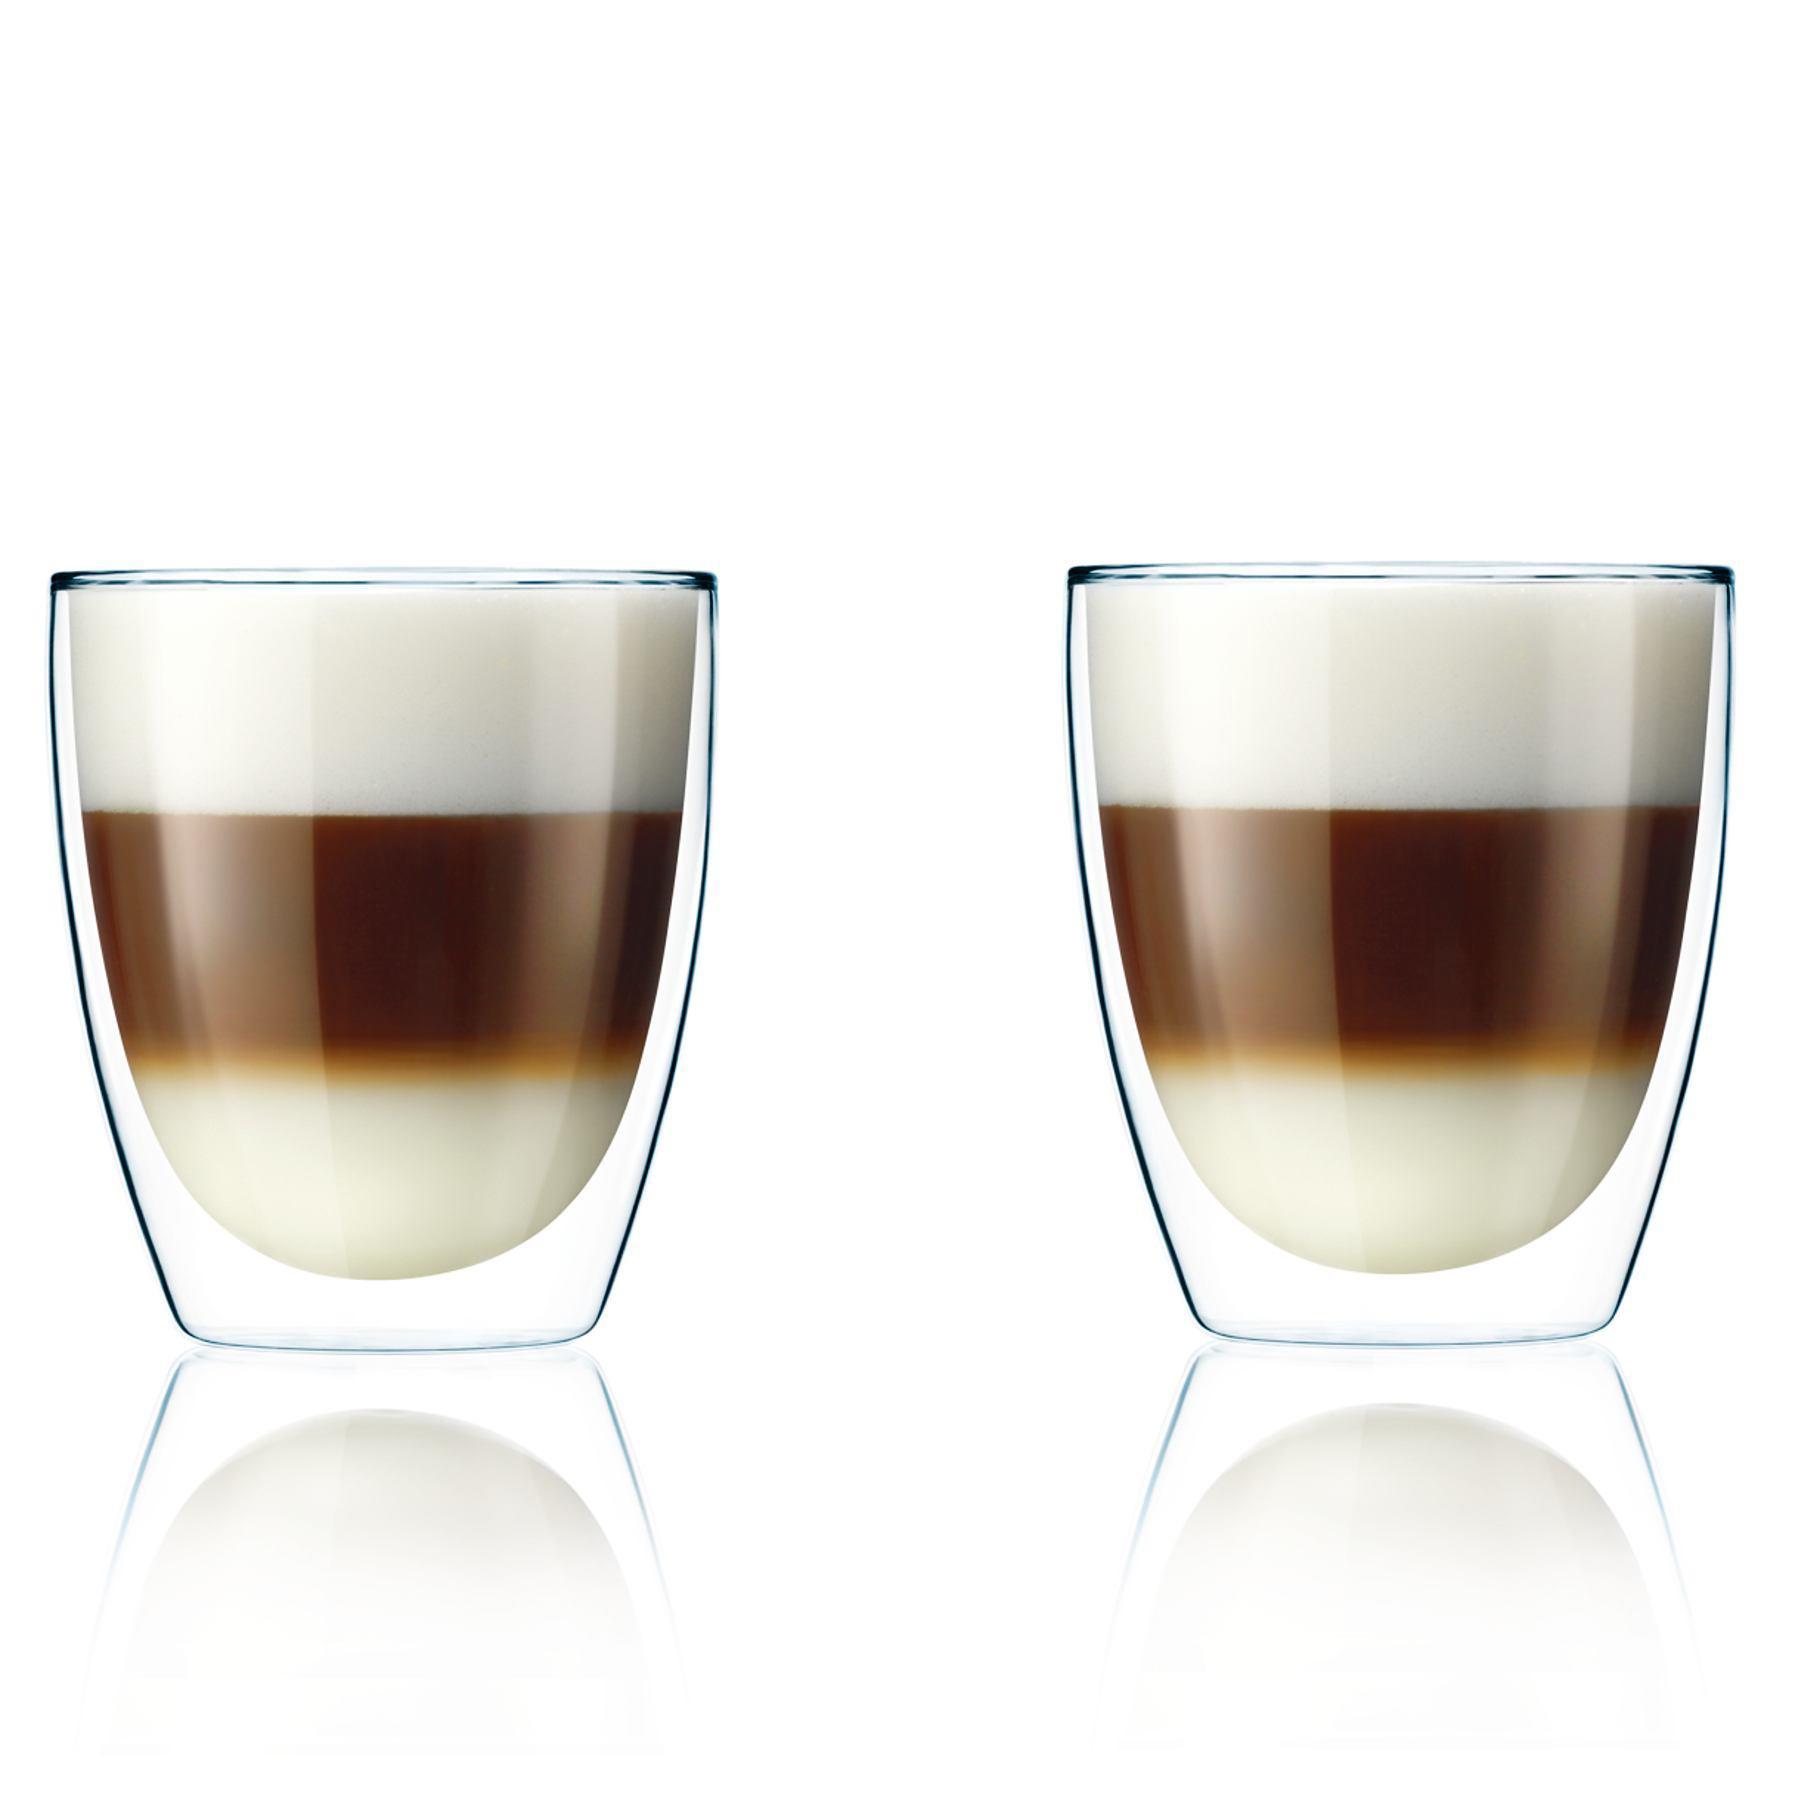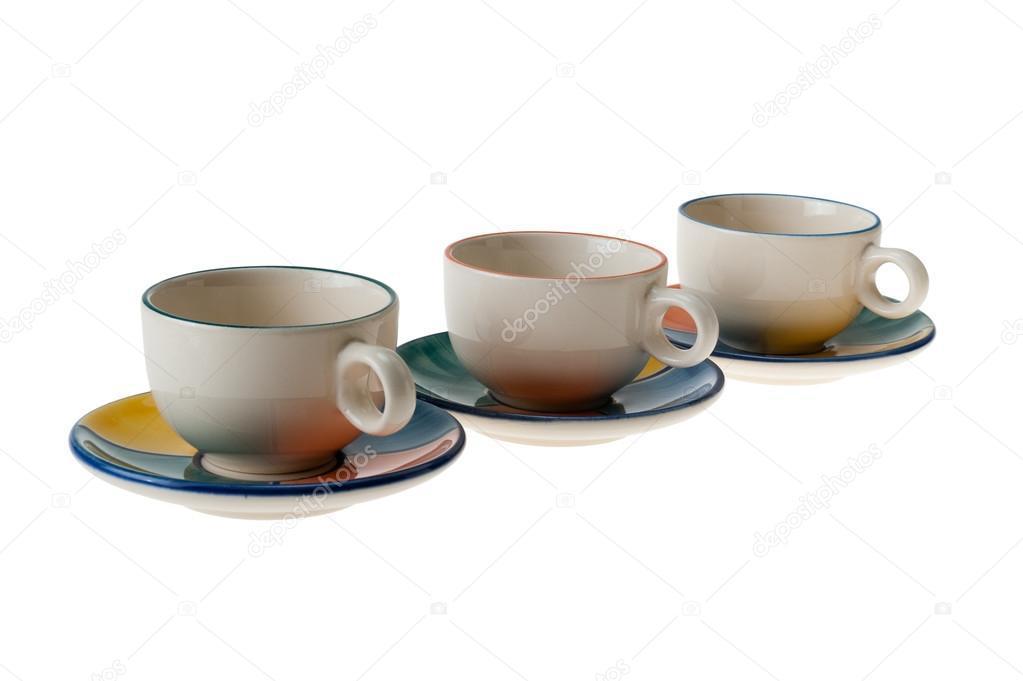The first image is the image on the left, the second image is the image on the right. Examine the images to the left and right. Is the description "An image shows a neat row of three matching cups and saucers." accurate? Answer yes or no. Yes. The first image is the image on the left, the second image is the image on the right. Given the left and right images, does the statement "There are three cups and three saucers in one of the images." hold true? Answer yes or no. Yes. 